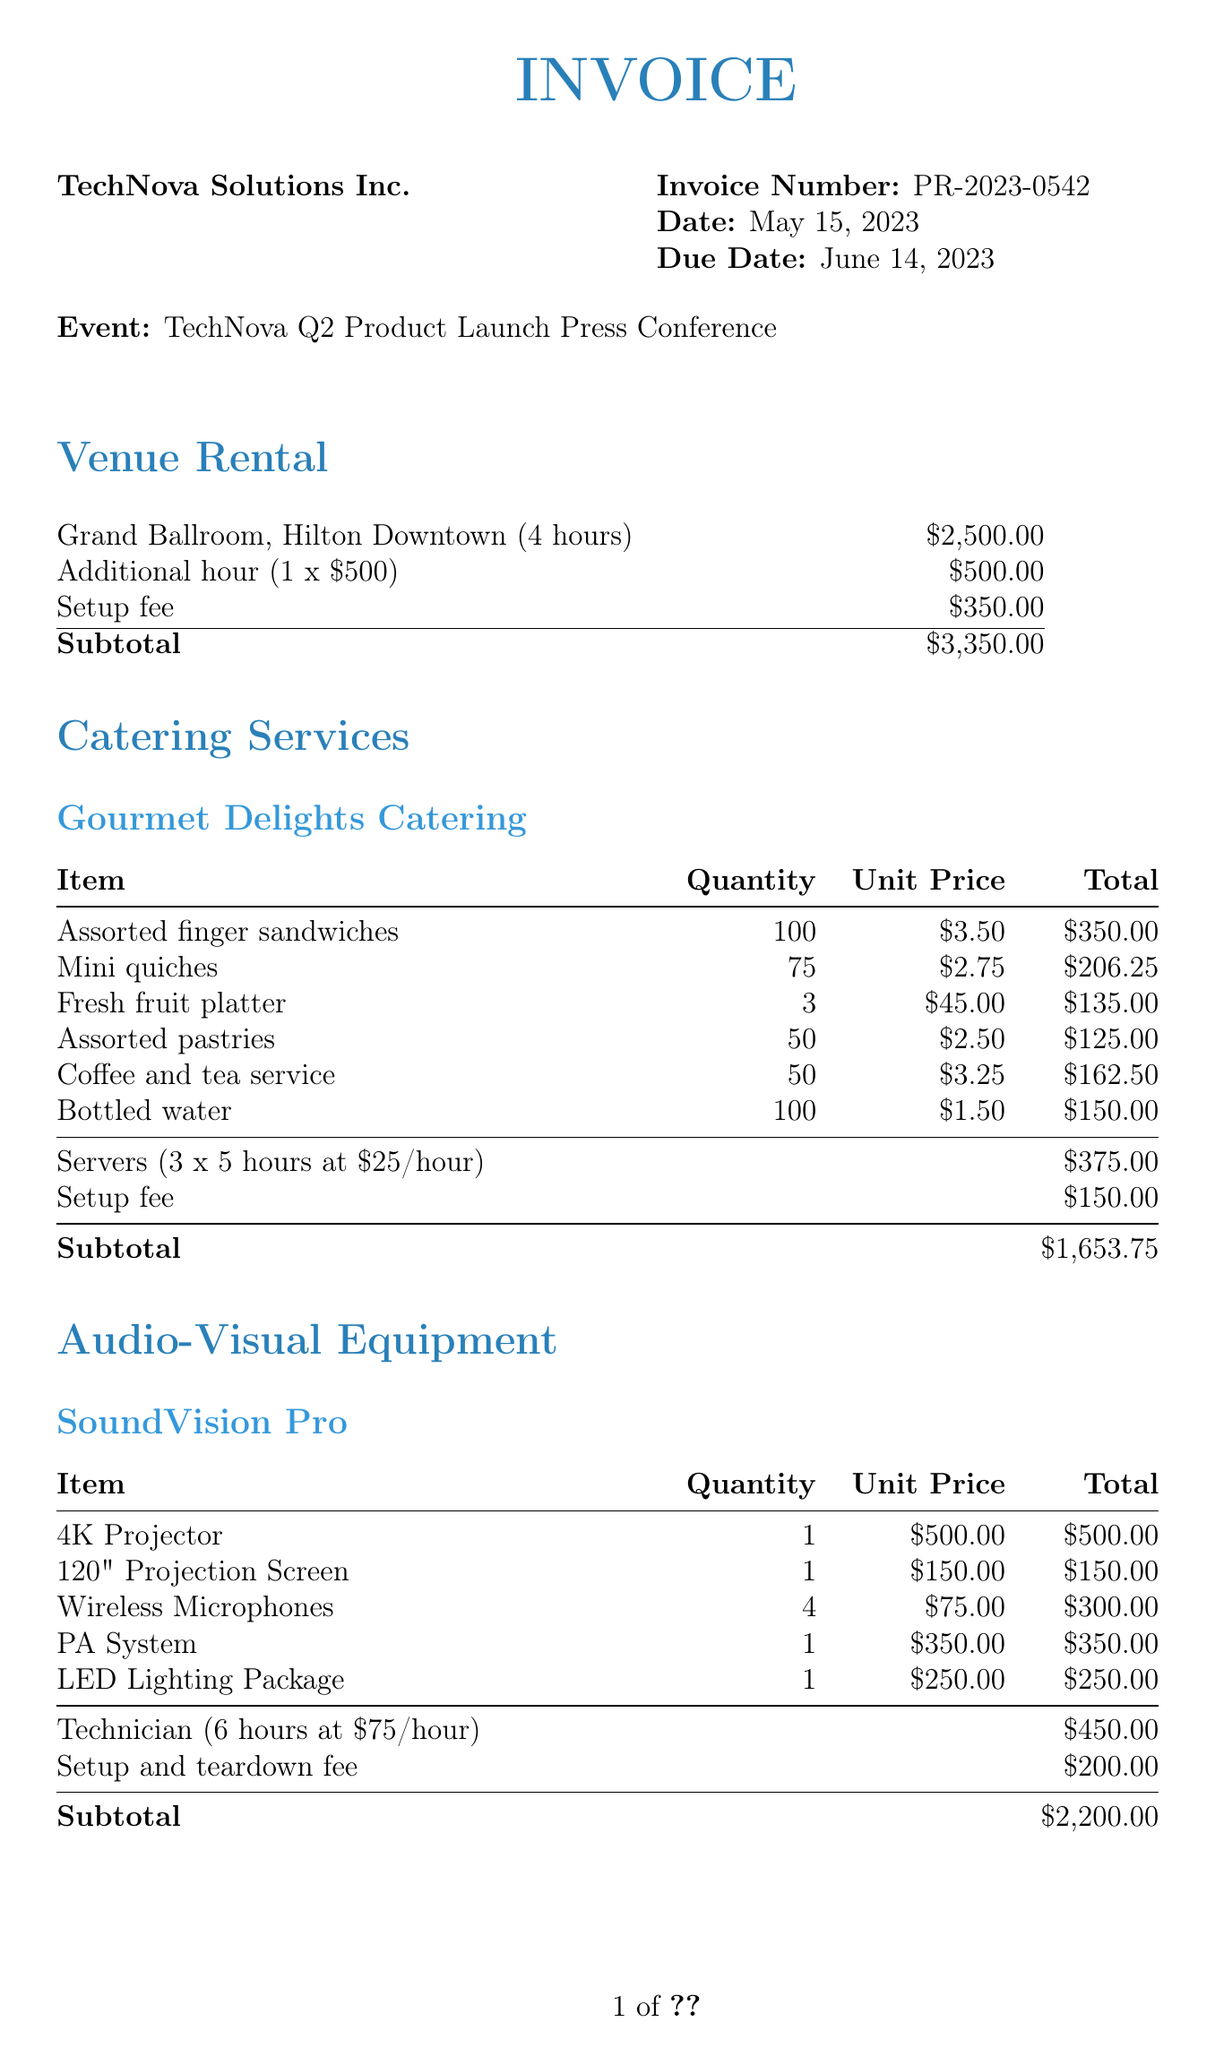what is the invoice number? The invoice number is listed in the invoice details section of the document.
Answer: PR-2023-0542 when is the due date? The due date is mentioned in the invoice details section.
Answer: June 14, 2023 how much was charged for venue rental setup fee? The setup fee for venue rental is detailed in the venue rental section.
Answer: $350.00 what is the subtotal for catering services? The subtotal for catering services is calculated in the catering services section based on individual item costs and additional charges.
Answer: $1,653.75 how many hours of event photography are included? The duration of event photography is specified in the additional services section.
Answer: 3 hours what is the total amount due? The total amount is calculated as the sum of subtotals for all sections in the invoice.
Answer: $8,803.75 who provided the audio-visual equipment? The provider of the audio-visual equipment is mentioned in the audio-visual equipment section.
Answer: SoundVision Pro how many servers were hired for catering? The number of servers is specified in the catering services section.
Answer: 3 what is the additional charge for one extra hour of venue rental? The rate for additional hours is provided in the venue rental section of the document.
Answer: $500.00 